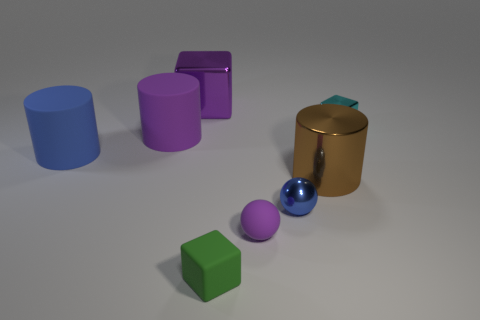Add 1 green blocks. How many green blocks are left? 2 Add 1 big brown metallic cylinders. How many big brown metallic cylinders exist? 2 Add 2 small brown blocks. How many objects exist? 10 Subtract all purple blocks. How many blocks are left? 2 Subtract all tiny cubes. How many cubes are left? 1 Subtract 0 brown balls. How many objects are left? 8 Subtract all cylinders. How many objects are left? 5 Subtract 2 cubes. How many cubes are left? 1 Subtract all blue spheres. Subtract all yellow cubes. How many spheres are left? 1 Subtract all yellow blocks. How many cyan balls are left? 0 